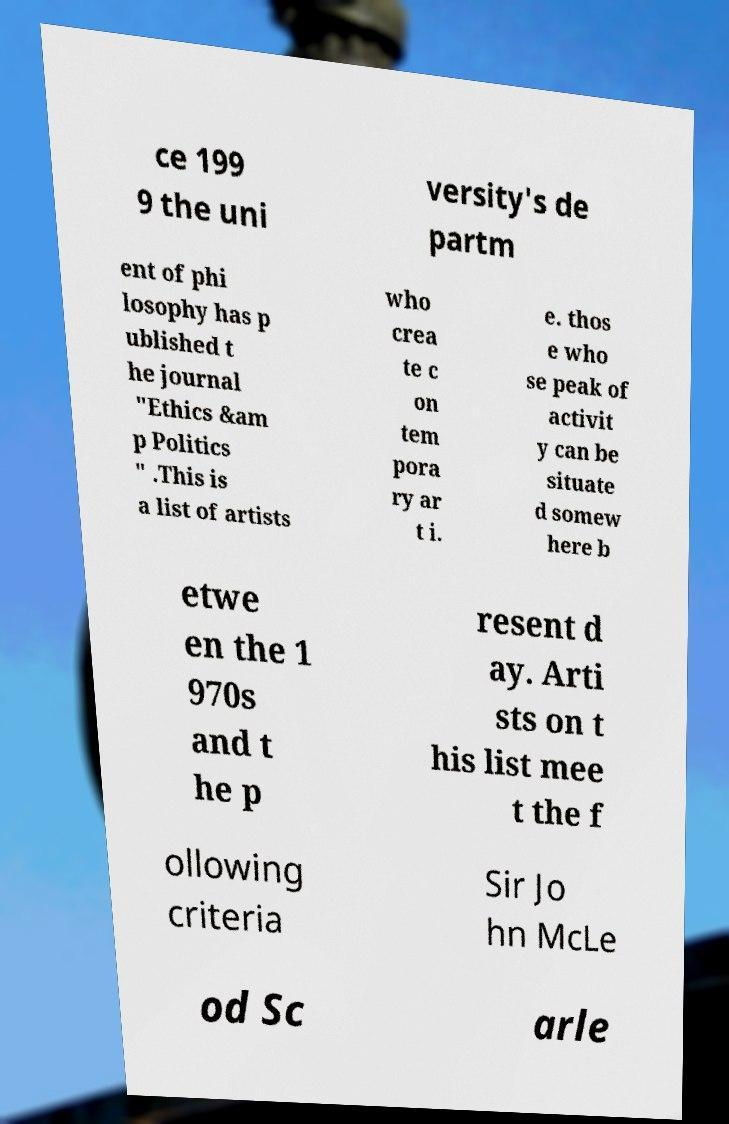For documentation purposes, I need the text within this image transcribed. Could you provide that? ce 199 9 the uni versity's de partm ent of phi losophy has p ublished t he journal "Ethics &am p Politics " .This is a list of artists who crea te c on tem pora ry ar t i. e. thos e who se peak of activit y can be situate d somew here b etwe en the 1 970s and t he p resent d ay. Arti sts on t his list mee t the f ollowing criteria Sir Jo hn McLe od Sc arle 